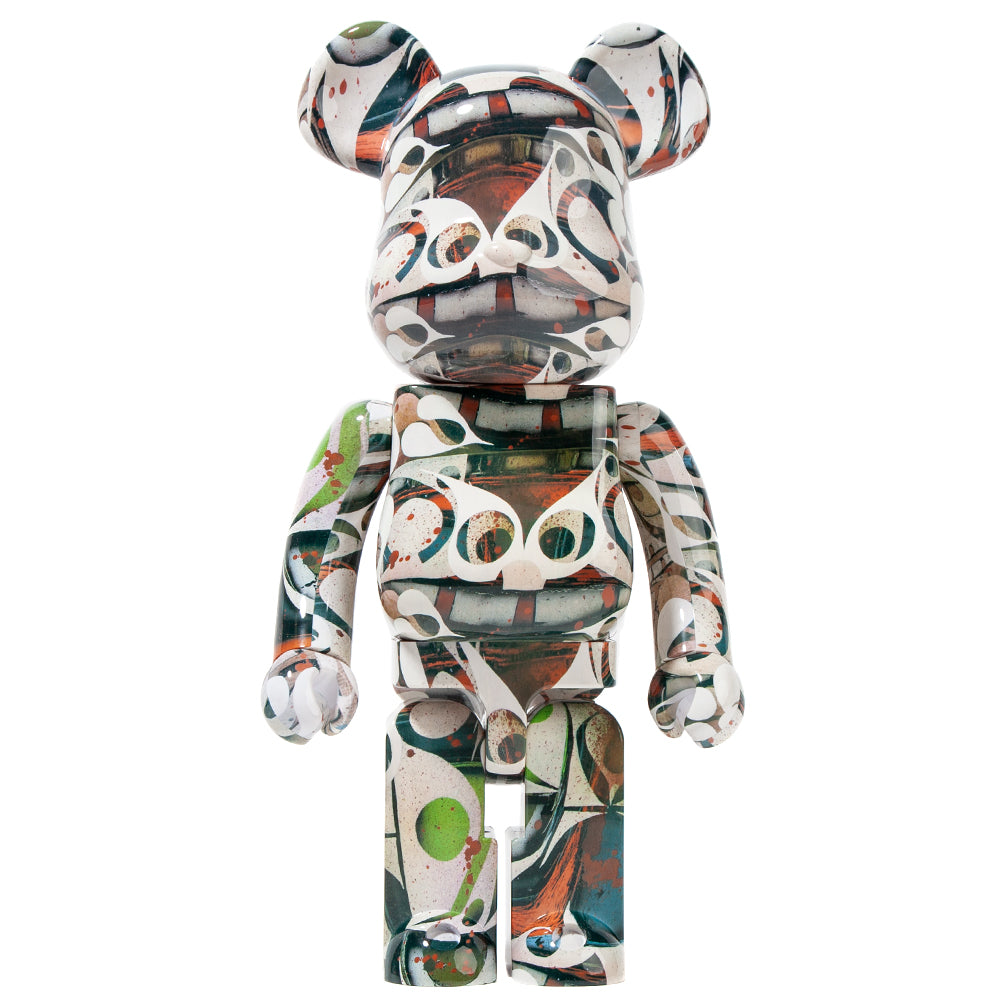Imagine this figurine in a real-life scenario. How might it be used or displayed? In a real-life scenario, this figurine could be displayed as a centerpiece in a modern art gallery, attracting art enthusiasts who appreciate abstract and contemporary art forms. It might also find its place in a chic urban loft, sitting atop a designer coffee table or an elegant bookshelf, adding a pop of color and artistic flair to the living space. Alternatively, it could be part of a larger collection of art toys, owned by a collector who values unique and limited-edition pieces that capture the essence of modern artistic expression. Its vibrant designs would make it a conversation starter, prompting discussions about art, creativity, and the fusion of various artistic influences.  Imagine this figurine in a bustling city setting, how might it come to life? In the heart of a bustling city, the figurine could come to life as a vibrant street performer, dancing and twirling to the rhythms of urban sounds. Its colorful patterns might glow in the neon lights, creating mesmerizing trails of motion that captivate pedestrians. The figurine could interact with passersby, spreading joy and inspiring creativity with its lively movements. It might also participate in art installations, collaborating with other animated artworks to create dynamic public spectacles that transform ordinary cityscapes into extraordinary realms of artistic expression. This lively animated figure would symbolize the pulse of the city, embodying the intersection of art, community, and the boundless imagination of urban life. 